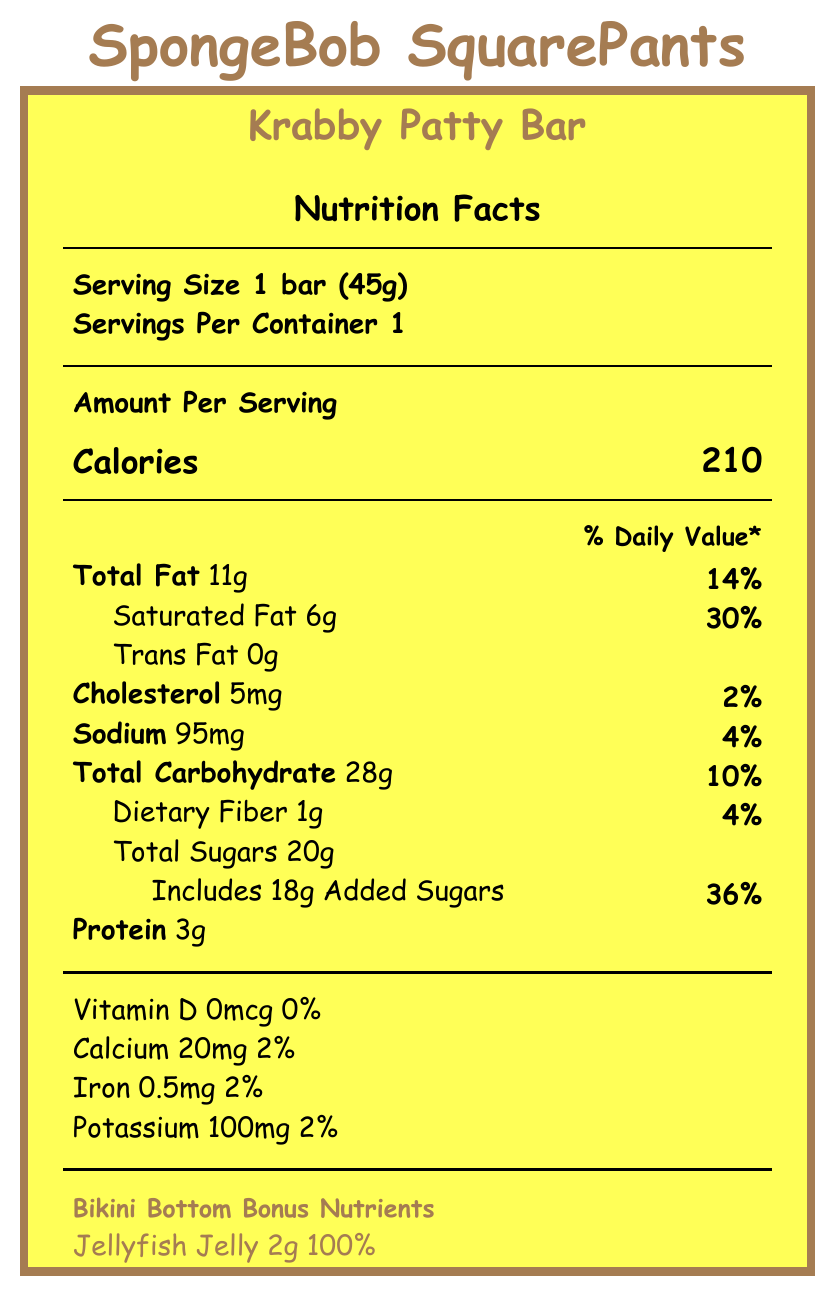what is the serving size for the Krabby Patty Bar? The serving size information is displayed prominently at the beginning of the Nutrition Facts label.
Answer: 1 bar (45g) how many calories are in one serving of the Krabby Patty Bar? The document lists the calories per serving as 210 under the "Amount Per Serving" section.
Answer: 210 what is the total fat content and its daily value percentage? The label specifies that the bar contains 11g of total fat, which is 14% of the daily value.
Answer: 11g, 14% how much added sugar is in the Krabby Patty Bar? The label displays that the bar includes 18g of added sugars, which is 36% of the daily value.
Answer: 18g what unique ingredients are listed that pertain to the show's storyline? The document lists these special ingredients under "Bikini Bottom Bonus Nutrients".
Answer: Jellyfish Jelly, Sea Salt, Secret Formula, Barnacle Bits which nutrient has the highest percentage of daily value in the Krabby Patty Bar? Jellyfish Jelly has the highest daily value percentage at 100%.
Answer: Jellyfish Jelly, 100% how much protein is in one serving of the Krabby Patty Bar? The protein content is listed as 3g per serving.
Answer: 3g does the Krabby Patty Bar contain any trans fat? The label clearly lists Trans Fat as 0g.
Answer: No is the Krabby Patty Bar high in saturated fat? The bar contains 6g of saturated fat, which is 30% of the daily value, indicating it is relatively high in saturated fat.
Answer: Yes what allergens are present in the Krabby Patty Bar? The allergen information on the label lists milk, soy, and shellfish as allergens, with a note that it may also contain traces of nuts.
Answer: Milk, soy, shellfish (barnacle bits), may contain traces of nuts how much dietary fiber is in one serving of the Krabby Patty Bar? The dietary fiber content is listed as 1g, which is 4% of the daily value.
Answer: 1g what is the fun fact mentioned on the Krabby Patty Bar nutrition label? This fun information is included as a light-hearted note on the label.
Answer: Each Krabby Patty Bar contains 1% of your daily recommended Laughs! how many milligrams of potassium are in the Krabby Patty Bar? The potassium content is specified as 100mg per serving, which is 2% of the daily value.
Answer: 100mg which of the following is not a "Bikini Bottom Bonus Nutrient"? A. Jellyfish Jelly B. Barnacle Bits C. Sea Sponge D. Sea Salt The bonus nutrients include Jellyfish Jelly, Barnacle Bits, and Sea Salt; Sea Sponge is not listed.
Answer: C. Sea Sponge what is the amount of Sea Salt in the Krabby Patty Bar? The label lists Sea Salt as containing 0.5g, which is 5% of the daily value.
Answer: 0.5g does the packaging mimick SpongeBob's signature attire? The packaging is described to resemble SpongeBob's square pants with brown edges like his belt, featuring his face and the Krusty Krab logo.
Answer: Yes which nutrient does the Krabby Patty Bar not provide any daily value for? A. Vitamin D B. Calcium C. Iron D. Potassium The label indicates Vitamin D at 0mcg, providing 0% of the daily value.
Answer: A. Vitamin D what percentage of daily value does the Krabby Patty Bar contribute to the daily intake of calcium? It provides 20mg of calcium, which is 2% of the daily value.
Answer: 2% how many servings are in one container of the Krabby Patty Bar? The label specifies that there is 1 serving per container.
Answer: 1 summarize the key features of the Krabby Patty Bar's nutrition label. This summary covers the essential details of the nutrition label, including its design, nutritional content, special ingredients, allergen information, and a fun fact.
Answer: The Krabby Patty Bar, designed to resemble SpongeBob's attire, has a serving size of 45g, containing 210 calories, 11g total fat (14% DV), 28g total carbs (10% DV), and 3g protein. Special nutrients related to the show include Jellyfish Jelly (100% DV), Sea Salt (5% DV), Secret Formula, and Barnacle Bits (10% DV). Allergen information states milk, soy, shellfish, and possible traces of nuts. The fun fact reveals it provides 1% of daily recommended Laughs. is the "Secret Formula" nutrient's daily value provided? The daily value for the Secret Formula is noted as not established on the label.
Answer: No, it's listed as "Not established" which nutrient has a lower percentage of daily value, cholesterol or sodium? Cholesterol has a daily value percentage of 2%, while sodium is listed as 4%.
Answer: Cholesterol, 2% what is the ingredient used in the Krabby Patty Bar that is related to the show's secret recipe? The label includes "Secret Formula" as a special nutrient, linking to the show's storyline.
Answer: Secret Formula how much iron is in the Krabby Patty Bar? The iron content is listed as 0.5mg, which is 2% of the daily value.
Answer: 0.5mg 